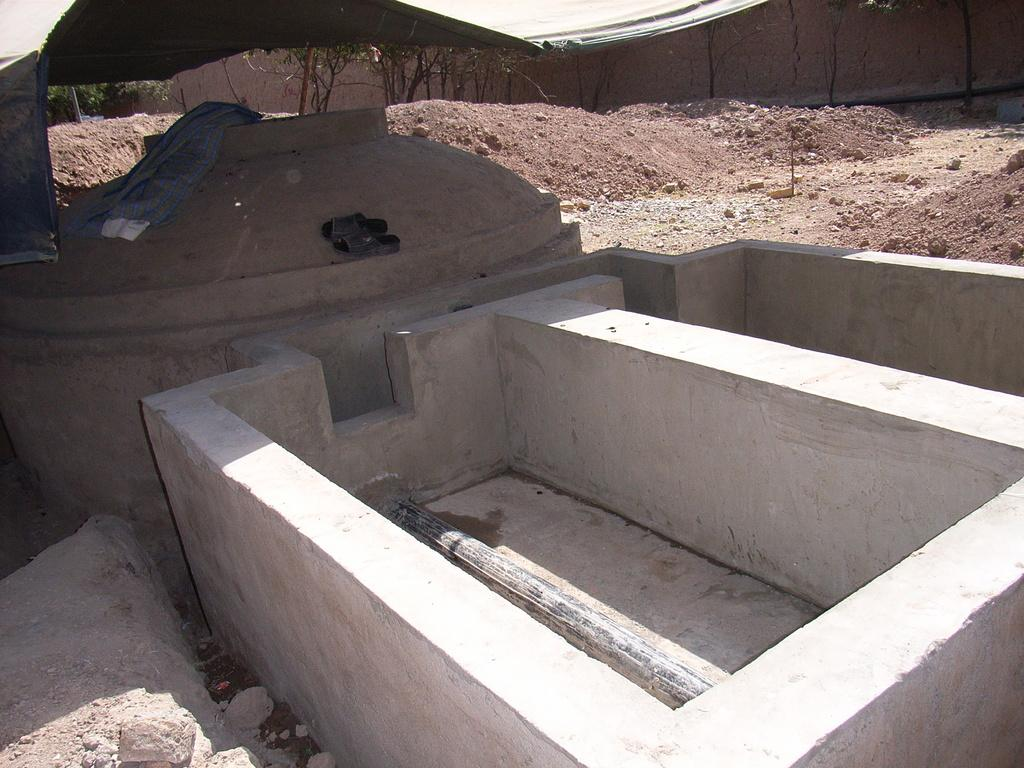What type of materials can be seen in the image? There are concrete blocks and stones in the image. What is the consistency of the substance between the blocks and stones? There is mud in the image. What structure is visible in the image? There is a wall in the image. What type of vegetation is present in the image? There are trees in the image. What type of meal is being prepared in the image? There is no meal being prepared in the image; it features concrete blocks, stones, mud, a wall, and trees. What amusement park ride can be seen in the image? There is no amusement park ride present in the image. 